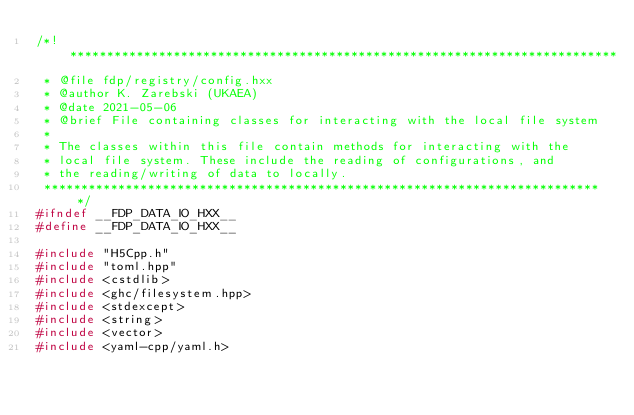<code> <loc_0><loc_0><loc_500><loc_500><_C++_>/*! **************************************************************************
 * @file fdp/registry/config.hxx
 * @author K. Zarebski (UKAEA)
 * @date 2021-05-06
 * @brief File containing classes for interacting with the local file system
 *
 * The classes within this file contain methods for interacting with the
 * local file system. These include the reading of configurations, and
 * the reading/writing of data to locally.
 ****************************************************************************/
#ifndef __FDP_DATA_IO_HXX__
#define __FDP_DATA_IO_HXX__

#include "H5Cpp.h"
#include "toml.hpp"
#include <cstdlib>
#include <ghc/filesystem.hpp>
#include <stdexcept>
#include <string>
#include <vector>
#include <yaml-cpp/yaml.h></code> 